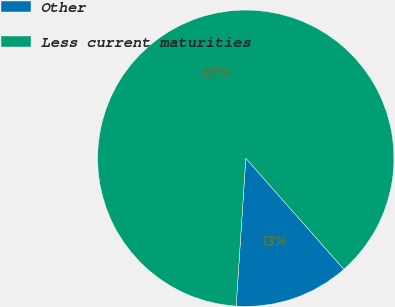<chart> <loc_0><loc_0><loc_500><loc_500><pie_chart><fcel>Other<fcel>Less current maturities<nl><fcel>12.55%<fcel>87.45%<nl></chart> 